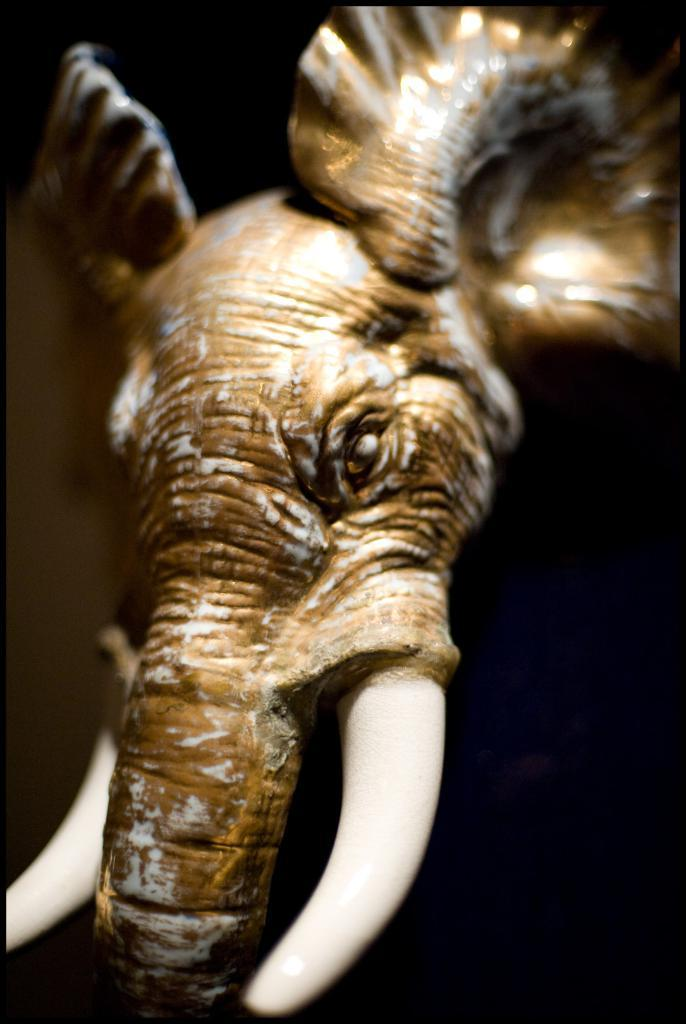What is the main subject of the image? There is a sculpture in the image. Can you describe the background of the image? The background of the image is dark. How many eggs are used in the development of the sculpture's acoustics? There is no mention of eggs or acoustics in the image, so it is not possible to answer that question. 